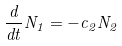<formula> <loc_0><loc_0><loc_500><loc_500>\frac { d } { d t } N _ { 1 } = - c _ { 2 } N _ { 2 }</formula> 